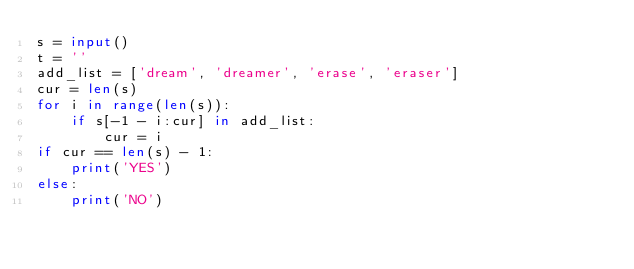Convert code to text. <code><loc_0><loc_0><loc_500><loc_500><_Python_>s = input()
t = ''
add_list = ['dream', 'dreamer', 'erase', 'eraser']
cur = len(s)
for i in range(len(s)):
    if s[-1 - i:cur] in add_list:
        cur = i
if cur == len(s) - 1:
    print('YES')
else:
    print('NO')</code> 